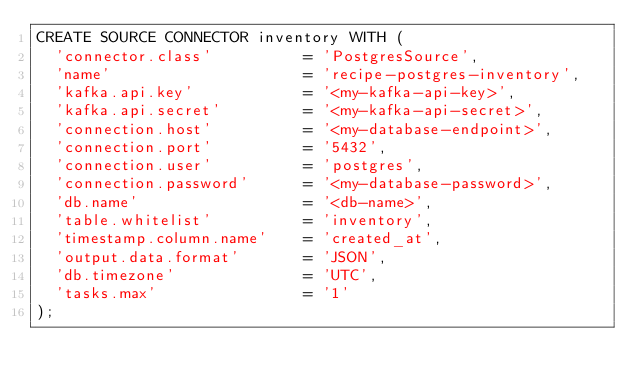<code> <loc_0><loc_0><loc_500><loc_500><_SQL_>CREATE SOURCE CONNECTOR inventory WITH (
  'connector.class'          = 'PostgresSource',
  'name'                     = 'recipe-postgres-inventory',
  'kafka.api.key'            = '<my-kafka-api-key>',
  'kafka.api.secret'         = '<my-kafka-api-secret>',
  'connection.host'          = '<my-database-endpoint>',
  'connection.port'          = '5432',
  'connection.user'          = 'postgres',
  'connection.password'      = '<my-database-password>',
  'db.name'                  = '<db-name>',
  'table.whitelist'          = 'inventory',
  'timestamp.column.name'    = 'created_at',
  'output.data.format'       = 'JSON',
  'db.timezone'              = 'UTC',
  'tasks.max'                = '1'
);
</code> 